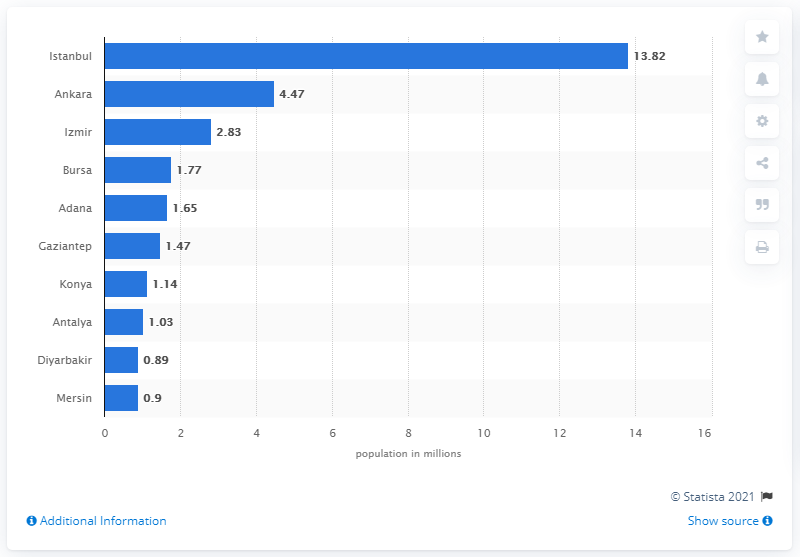Indicate a few pertinent items in this graphic. At the end of 2013, an estimated 13.82 people lived in Istanbul. 